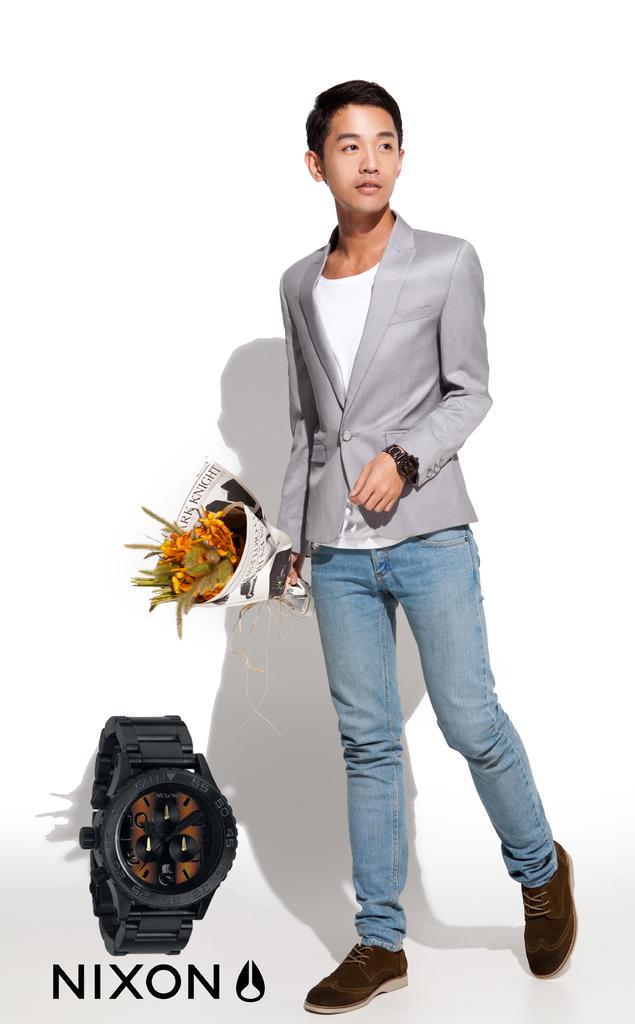What brand is this wristwatch?
Offer a very short reply. Nixon. 